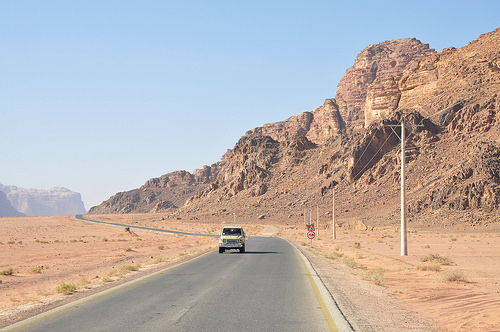<image>
Is the sign next to the road? Yes. The sign is positioned adjacent to the road, located nearby in the same general area. 